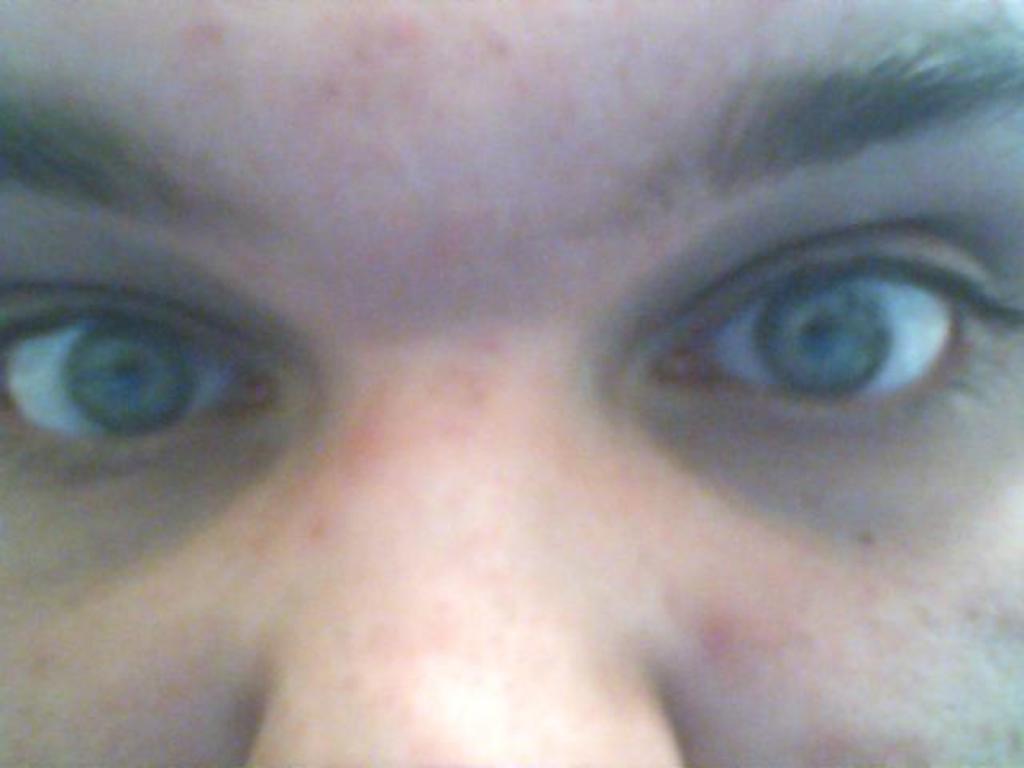In one or two sentences, can you explain what this image depicts? In this picture there is a face of a person, where we can see eyes and nose of a person. 